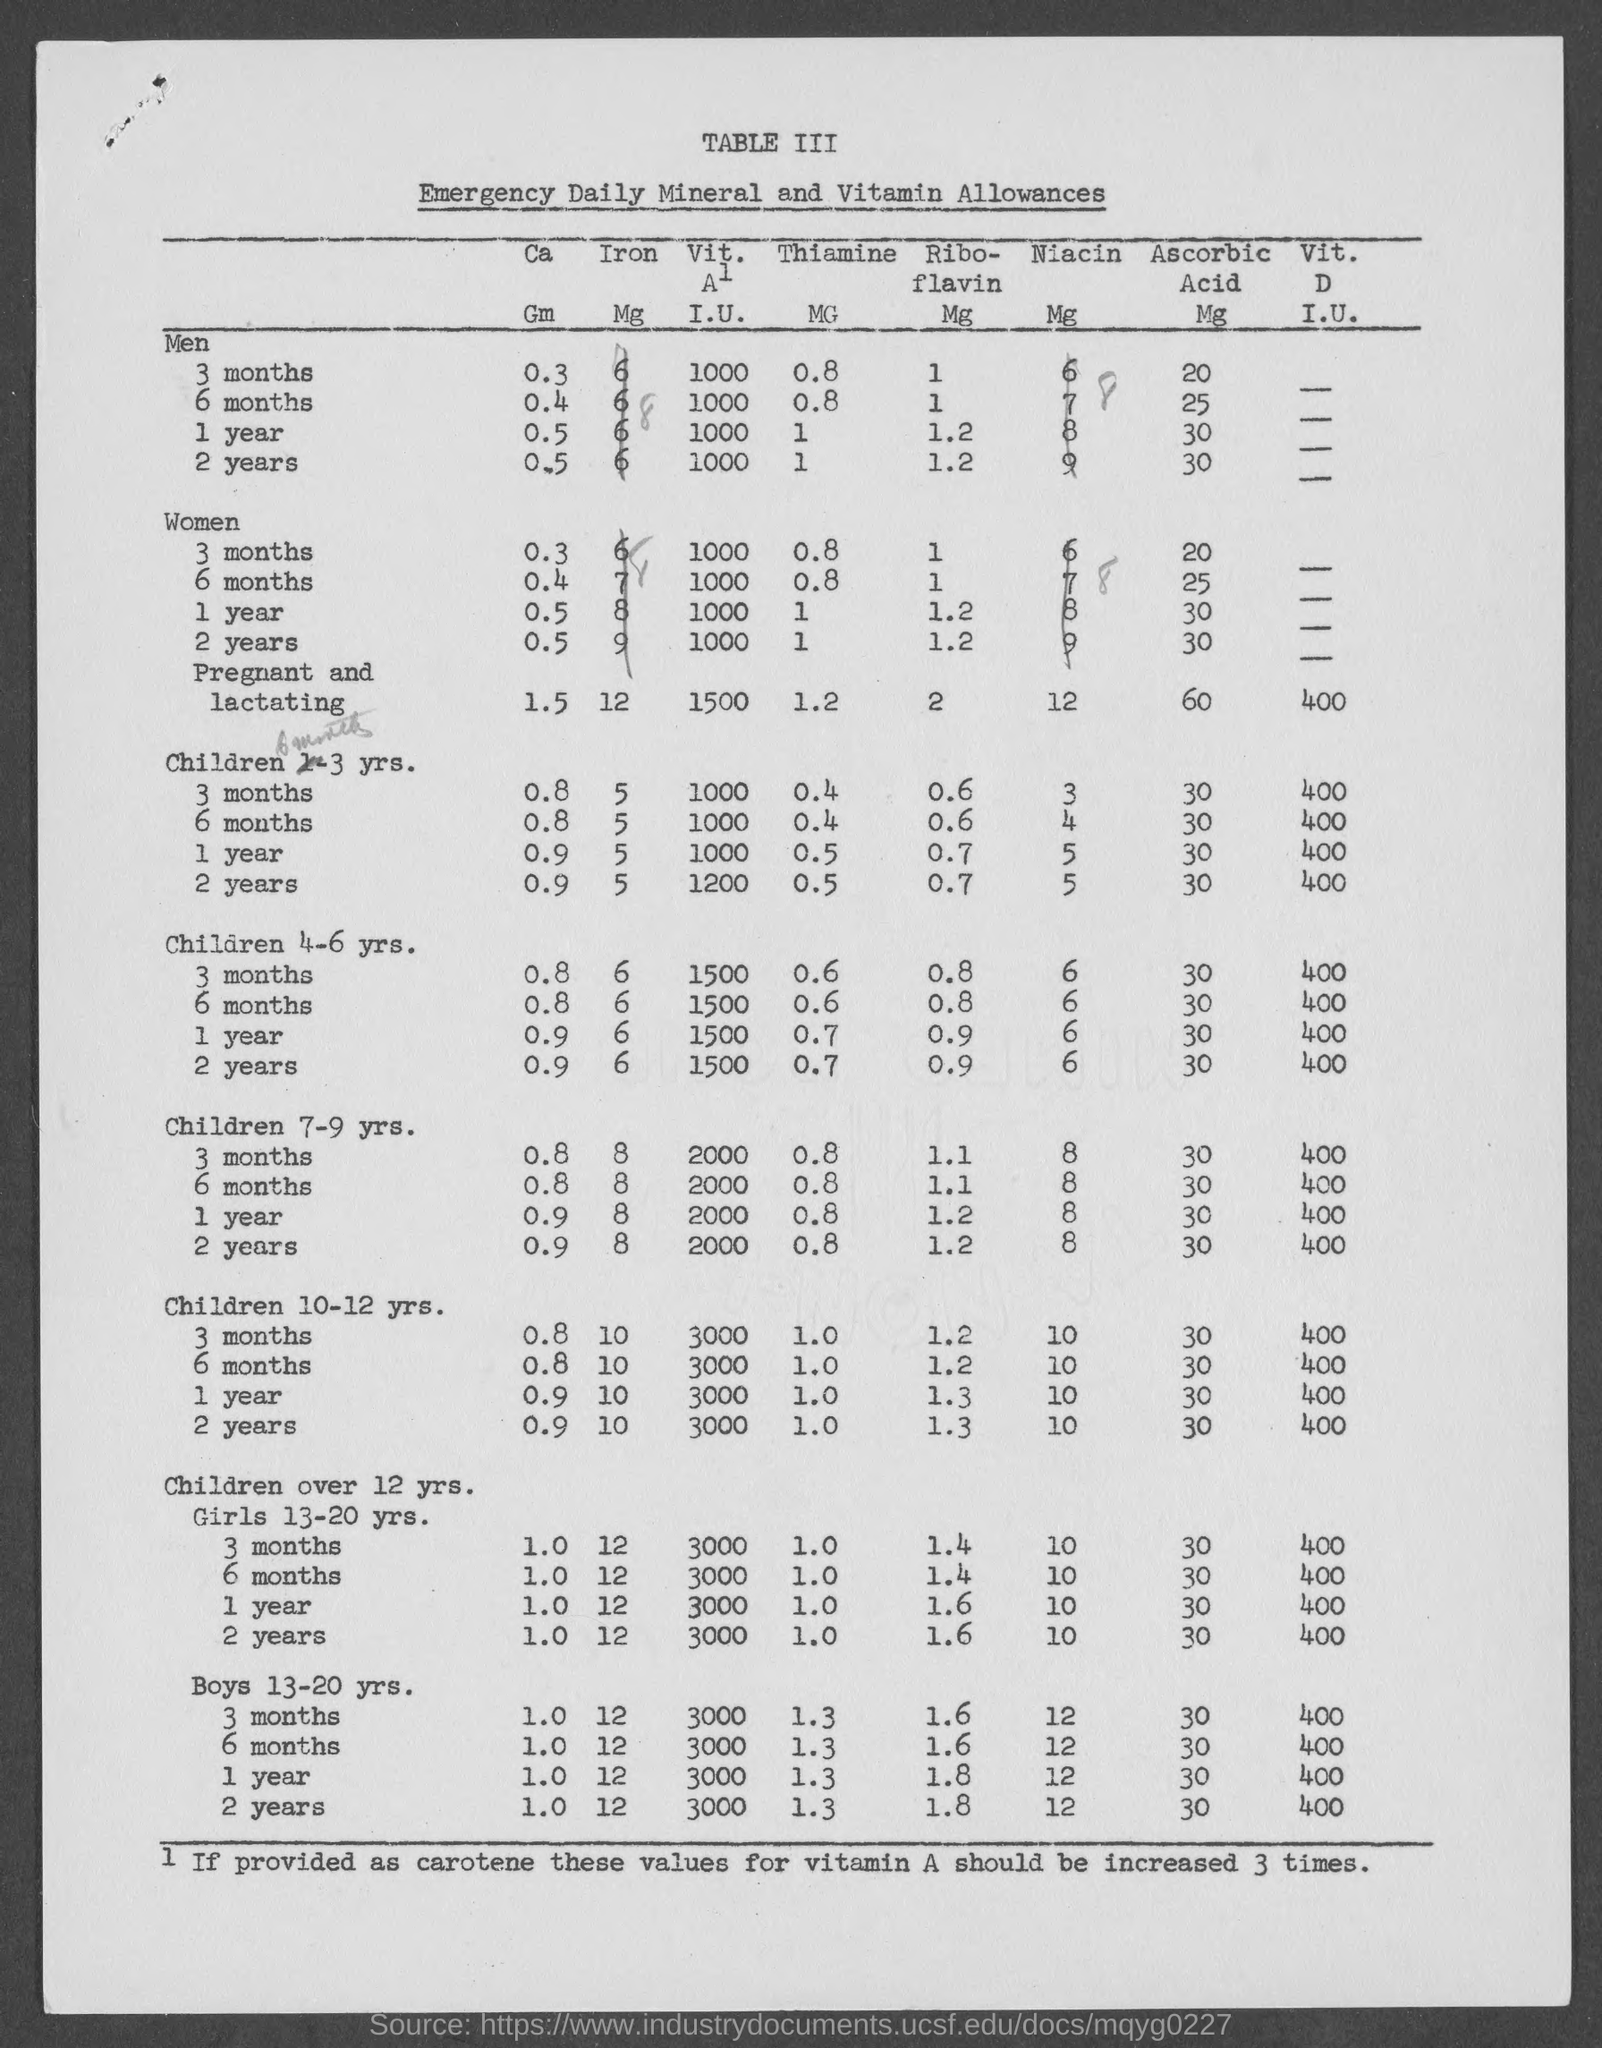What is the value for Men for 3 months under 'Ca' ?
Make the answer very short. 0.3. What is the value for Women for 2 years under 'Riboflavin' ?
Give a very brief answer. 1.2. What is the topmost word written in this document in capital letters?
Provide a succinct answer. Table iii. How much times these values for vitamin A should be increased if provided as carotene?
Provide a short and direct response. 3 times. What is the value for men for 1 year under 'ascorbic' ?
Your answer should be very brief. 30. What is the value for Children 4-6 yrs. for 6 months under 'Ca' ?
Your answer should be very brief. 0.8. What is the value for Children 10-12 years for 2 years under Thiamine ?
Offer a terse response. 1.0. What is the value for Boys 13-20 years for 6 months under 'Ca' ?
Make the answer very short. 1.0. Emergency daily allowances of what substance given here in this list ?
Your response must be concise. Mineral and vitamin allowances. What is the value for Children 7-9 yrs. for 6 months under 'Ribo-' ?
Your answer should be compact. 1.1. 